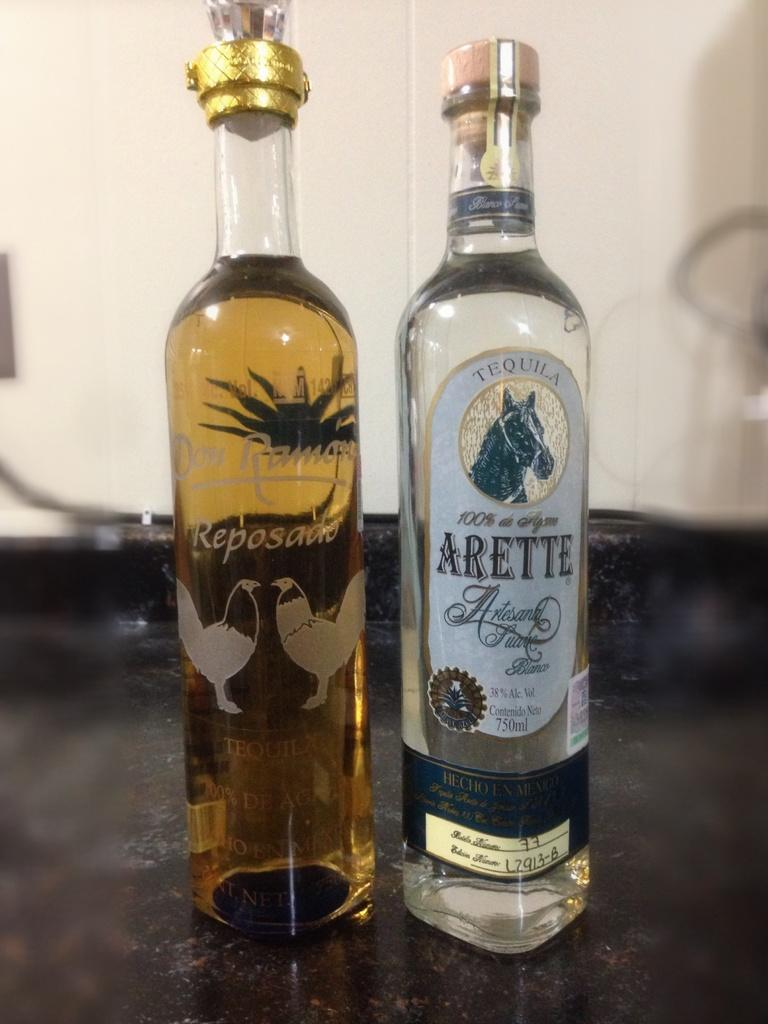<image>
Write a terse but informative summary of the picture. two bottles of tequila with the one of the left being a reposado 